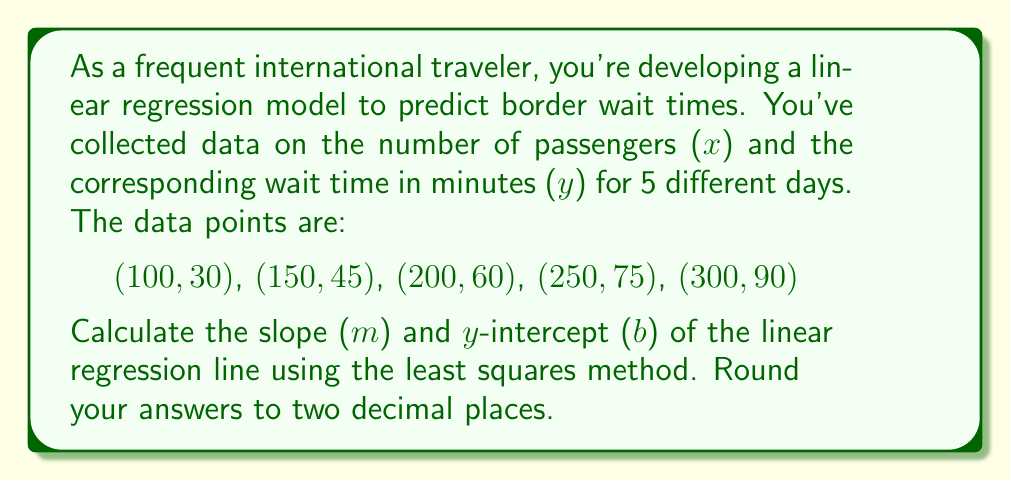Could you help me with this problem? To find the slope (m) and y-intercept (b) of the linear regression line, we'll use the least squares method. The formulas for m and b are:

$$m = \frac{n\sum xy - \sum x \sum y}{n\sum x^2 - (\sum x)^2}$$

$$b = \frac{\sum y - m\sum x}{n}$$

Where n is the number of data points.

Step 1: Calculate the necessary sums:
n = 5
$\sum x = 100 + 150 + 200 + 250 + 300 = 1000$
$\sum y = 30 + 45 + 60 + 75 + 90 = 300$
$\sum xy = (100 \times 30) + (150 \times 45) + (200 \times 60) + (250 \times 75) + (300 \times 90) = 72,500$
$\sum x^2 = 100^2 + 150^2 + 200^2 + 250^2 + 300^2 = 262,500$

Step 2: Calculate the slope (m):
$$m = \frac{5(72,500) - 1000(300)}{5(262,500) - 1000^2}$$
$$m = \frac{362,500 - 300,000}{1,312,500 - 1,000,000}$$
$$m = \frac{62,500}{312,500} = 0.20$$

Step 3: Calculate the y-intercept (b):
$$b = \frac{300 - 0.20(1000)}{5}$$
$$b = \frac{300 - 200}{5} = \frac{100}{5} = 20$$

Therefore, the equation of the linear regression line is:
$$y = 0.20x + 20$$

Where y is the predicted wait time in minutes, and x is the number of passengers.
Answer: Slope (m) = 0.20
Y-intercept (b) = 20.00 